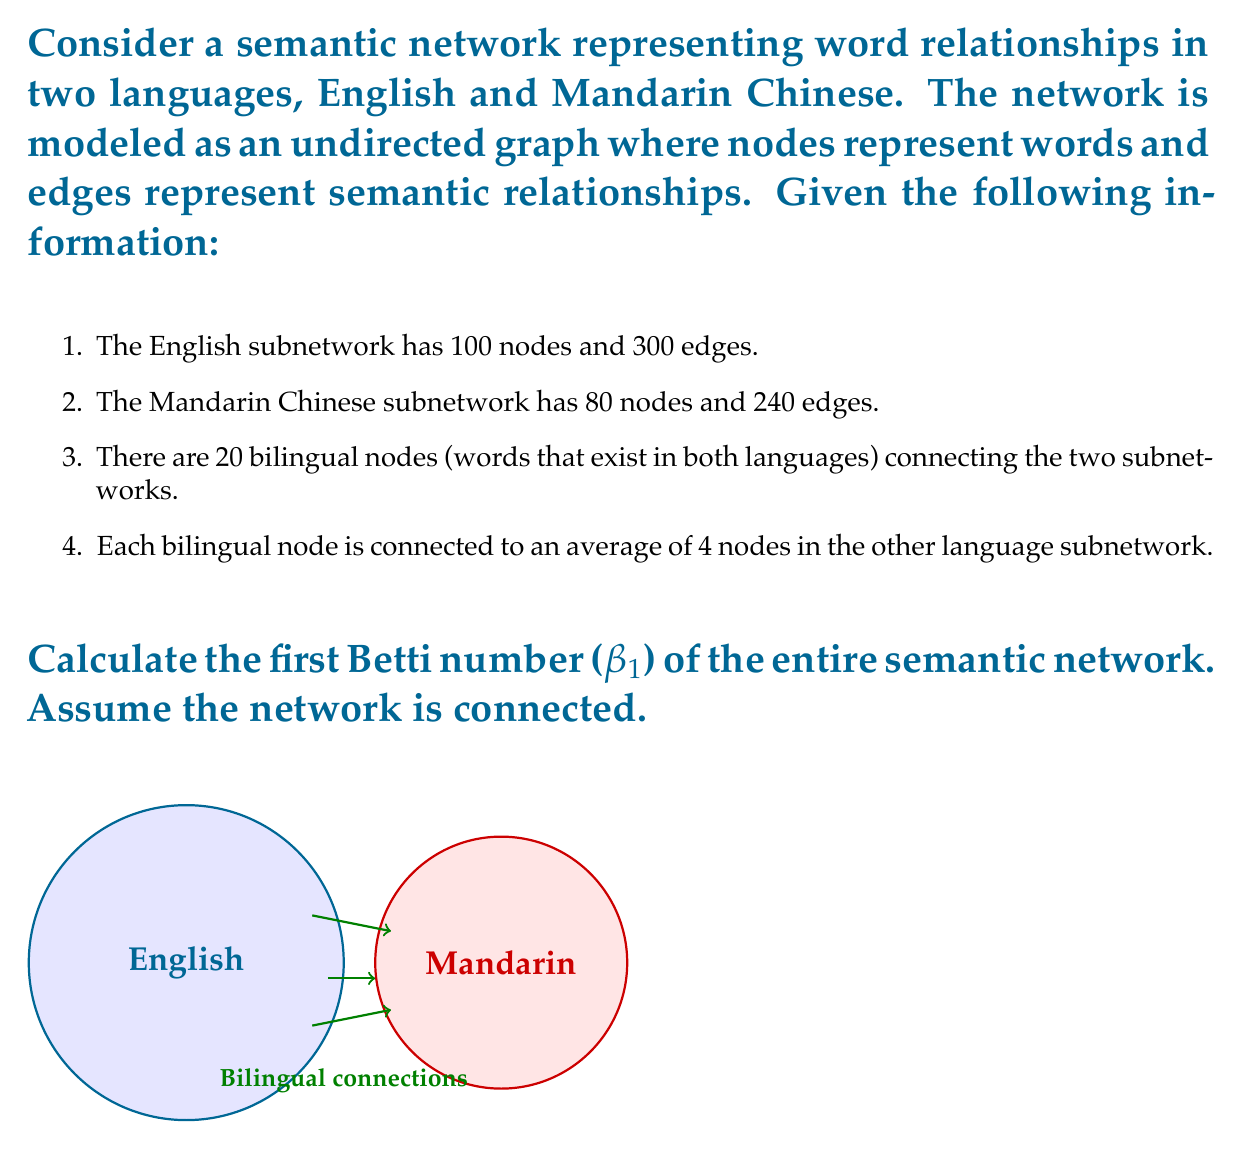Teach me how to tackle this problem. Let's approach this step-by-step:

1) First, we need to calculate the total number of nodes (V) and edges (E) in the entire network:

   Nodes: $V = 100 + 80 - 20 = 160$ (subtracting 20 to avoid counting bilingual nodes twice)
   
   Edges: $E = 300 + 240 + (20 * 4) / 2 = 580$ (adding connections between subnetworks, dividing by 2 to avoid double-counting)

2) The first Betti number (β₁) is equal to the rank of the first homology group, which for a connected graph is given by the formula:

   $β₁ = E - V + 1$

   This formula comes from the Euler characteristic of the graph and represents the number of independent cycles in the network.

3) Substituting our values:

   $β₁ = 580 - 160 + 1 = 421$

4) Therefore, the first Betti number of the entire semantic network is 421.

This number represents the number of independent cycles in the network, which in the context of semantic networks, could indicate the richness of interconnected meanings and concepts across the two languages.
Answer: 421 